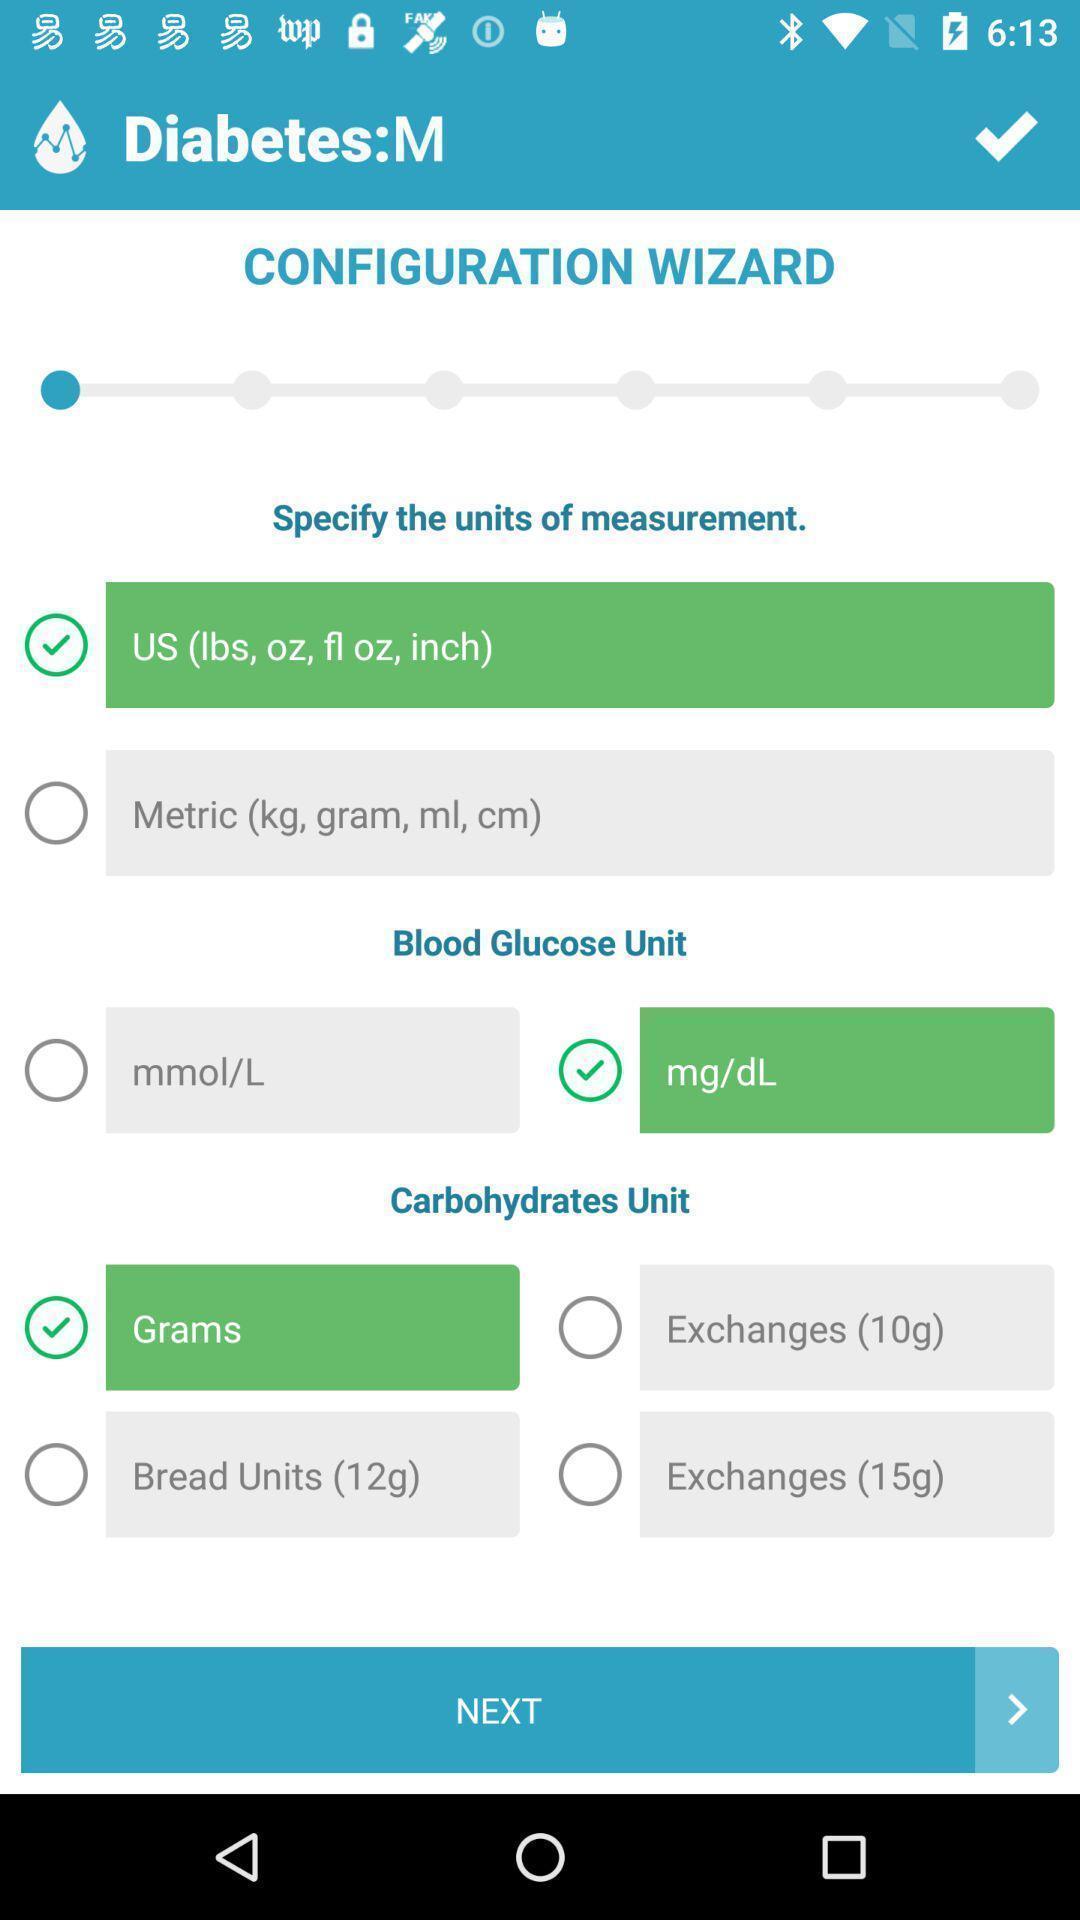Please provide a description for this image. Page shows the measurement of diabetes on health app. 